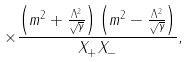Convert formula to latex. <formula><loc_0><loc_0><loc_500><loc_500>\times \frac { \left ( m ^ { 2 } + \frac { \Lambda ^ { 2 } } { \sqrt { \gamma } } \right ) \left ( m ^ { 2 } - \frac { \Lambda ^ { 2 } } { \sqrt { \gamma } } \right ) } { X _ { + } X _ { - } } ,</formula> 